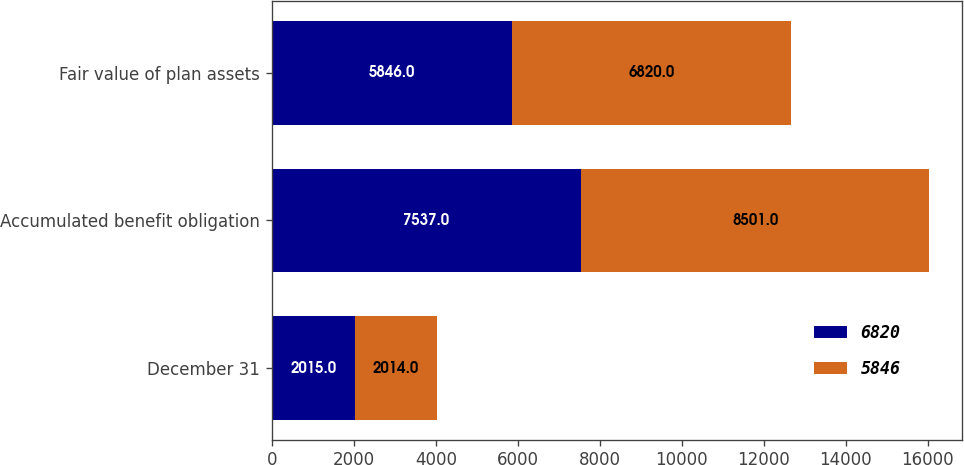Convert chart. <chart><loc_0><loc_0><loc_500><loc_500><stacked_bar_chart><ecel><fcel>December 31<fcel>Accumulated benefit obligation<fcel>Fair value of plan assets<nl><fcel>6820<fcel>2015<fcel>7537<fcel>5846<nl><fcel>5846<fcel>2014<fcel>8501<fcel>6820<nl></chart> 